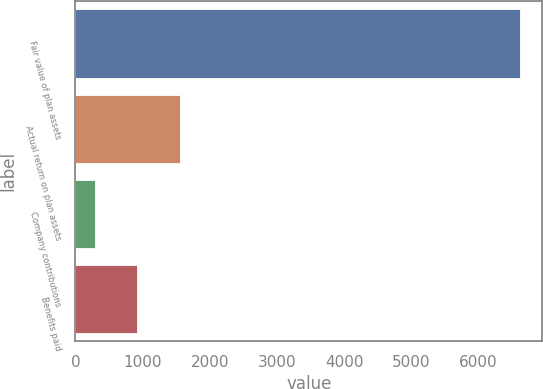<chart> <loc_0><loc_0><loc_500><loc_500><bar_chart><fcel>Fair value of plan assets<fcel>Actual return on plan assets<fcel>Company contributions<fcel>Benefits paid<nl><fcel>6616<fcel>1555.2<fcel>290<fcel>922.6<nl></chart> 